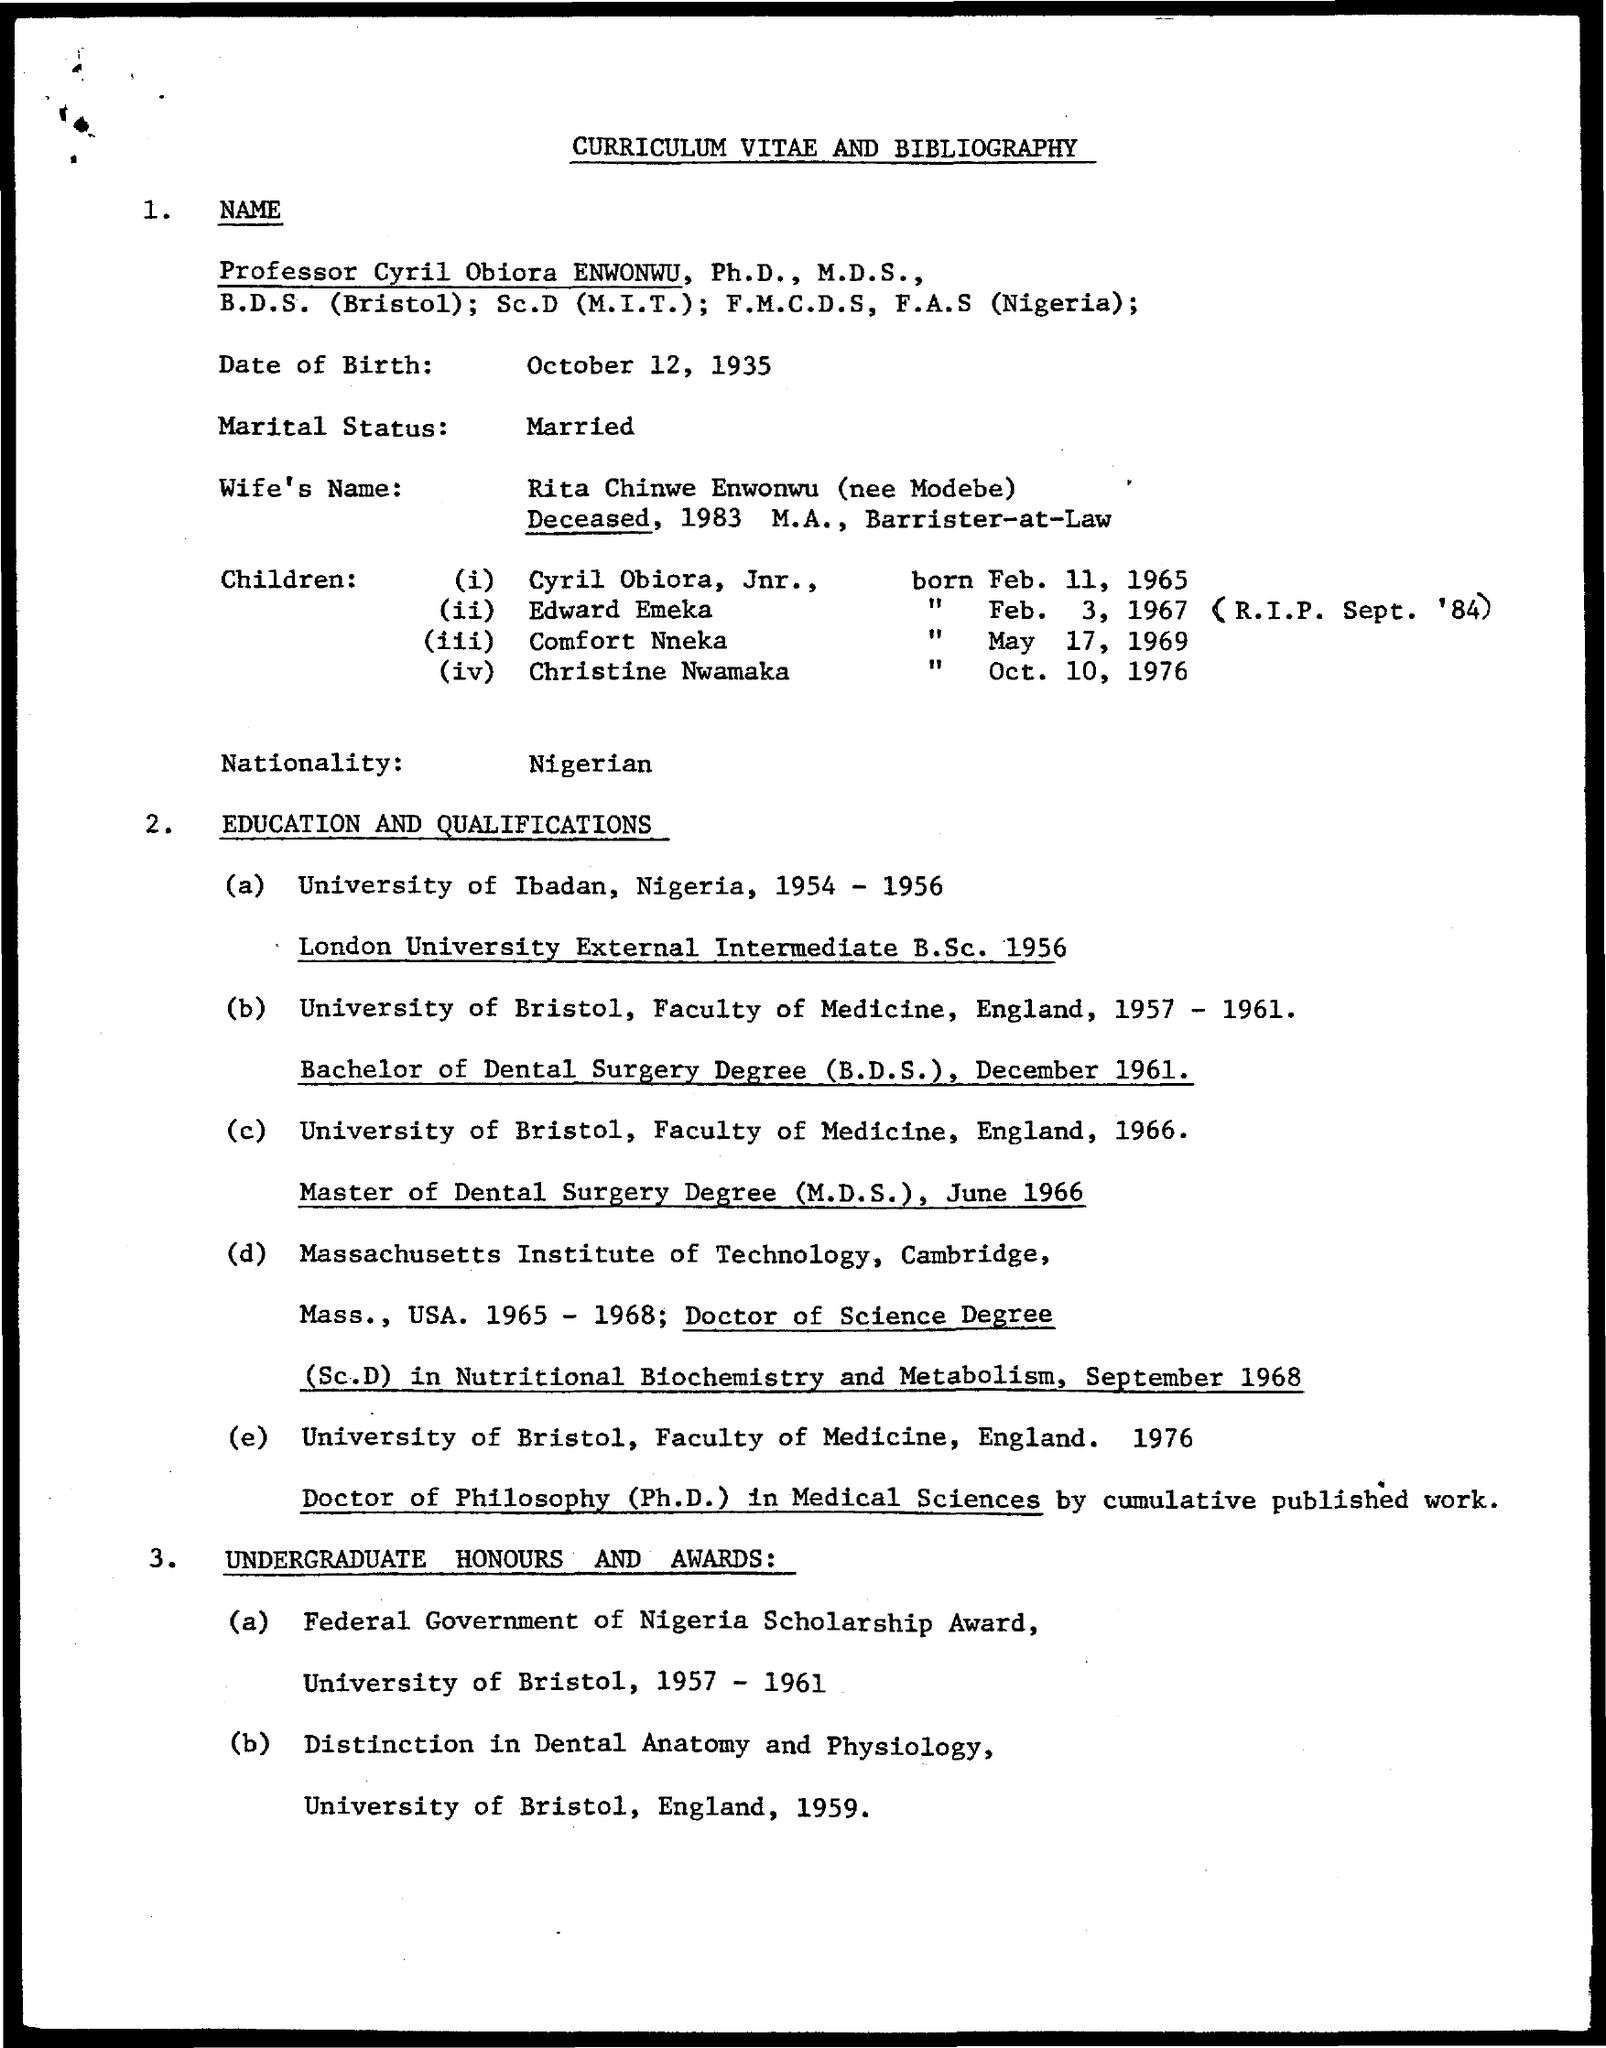Who's curriculum vitae and bibliography is given here?
Provide a short and direct response. PROFESSOR CYRIL OBIORA ENWONWU, PH.D., M.D.S.,. What is the date of birth of Cyril Obiora ENWONWU?
Ensure brevity in your answer.  OCTOBER 12, 1935. Who is the wife of Cyril Obiora ENWONWU?
Make the answer very short. Rita Chinwe Enwonwu (nee Modebe). What is the marital status of Cyril Obiora ENWONWU?
Your response must be concise. MARRIED. What is the nationality of Cyril Obiora ENWONWU?
Your answer should be compact. NIGERIAN. In which university, Cyril Obiora ENWONWU has completed his B.D.S degree?
Provide a short and direct response. UNIVERSITY OF BRISTOL. When did Cyril Obiora ENWONWU completed Ph.D. degree in Medical Science?
Make the answer very short. 1976. Which award was won by Cyril Obiora ENWONWU during the year 1957 - 1961?
Your response must be concise. FEDERAL GOVERNMENT OF NIGERIA SCHOLARSHIP AWARD. 